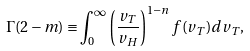Convert formula to latex. <formula><loc_0><loc_0><loc_500><loc_500>\Gamma ( 2 - m ) \equiv \int _ { 0 } ^ { \infty } \left ( \frac { v _ { T } } { v _ { H } } \right ) ^ { 1 - n } f ( v _ { T } ) d v _ { T } ,</formula> 